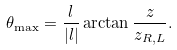Convert formula to latex. <formula><loc_0><loc_0><loc_500><loc_500>\theta _ { \max } = \frac { l } { | l | } \arctan \frac { z } { z _ { R , L } } .</formula> 